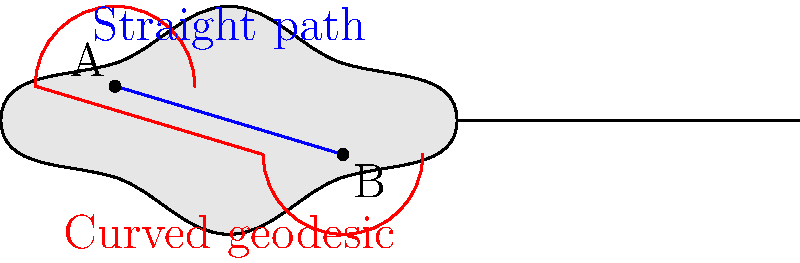On a guitar-shaped non-Euclidean surface, two points A and B are marked as shown. The blue line represents the straight path between A and B, while the red curve represents the geodesic (shortest path) between these points. If the length of the straight path is $L$ and the length of the geodesic is $G$, which of the following statements is true?

a) $L < G$
b) $L = G$
c) $L > G$
d) The relationship between $L$ and $G$ cannot be determined without additional information To answer this question, let's consider the properties of geodesics in non-Euclidean geometry:

1. In Euclidean geometry, the shortest path between two points is always a straight line. However, this is not necessarily true in non-Euclidean geometry.

2. A geodesic is defined as the shortest path between two points on a curved surface.

3. On a non-Euclidean surface, like the guitar-shaped surface shown, the curvature of the space affects the path of geodesics.

4. The blue line represents the straight path between A and B, which would be the shortest path in Euclidean geometry.

5. The red curve represents the geodesic, which takes into account the curvature of the surface.

6. Since the geodesic is curved and deviates from the straight path, it must be following the contours of the surface in a way that minimizes the distance traveled.

7. By definition, the geodesic is the shortest path between two points on this curved surface.

Therefore, the length of the geodesic (G) must be shorter than the length of the straight path (L) on this non-Euclidean surface.

This leads us to conclude that $L > G$.
Answer: c) $L > G$ 